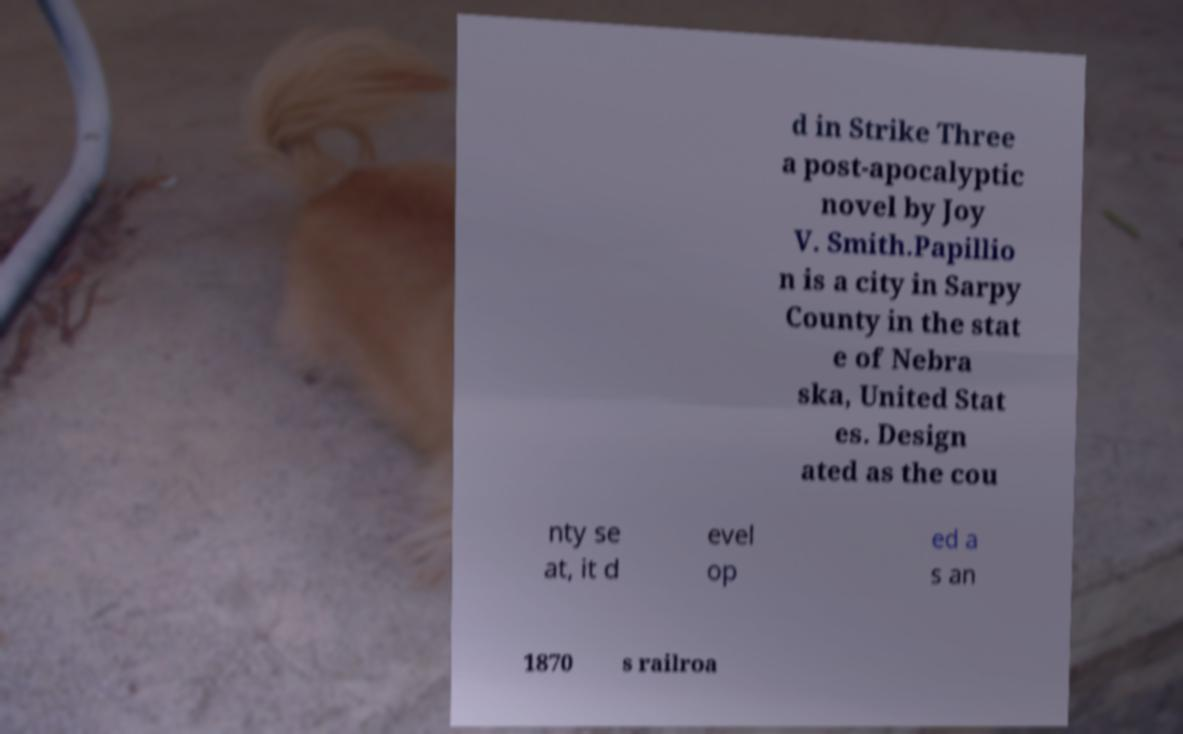Can you accurately transcribe the text from the provided image for me? d in Strike Three a post-apocalyptic novel by Joy V. Smith.Papillio n is a city in Sarpy County in the stat e of Nebra ska, United Stat es. Design ated as the cou nty se at, it d evel op ed a s an 1870 s railroa 